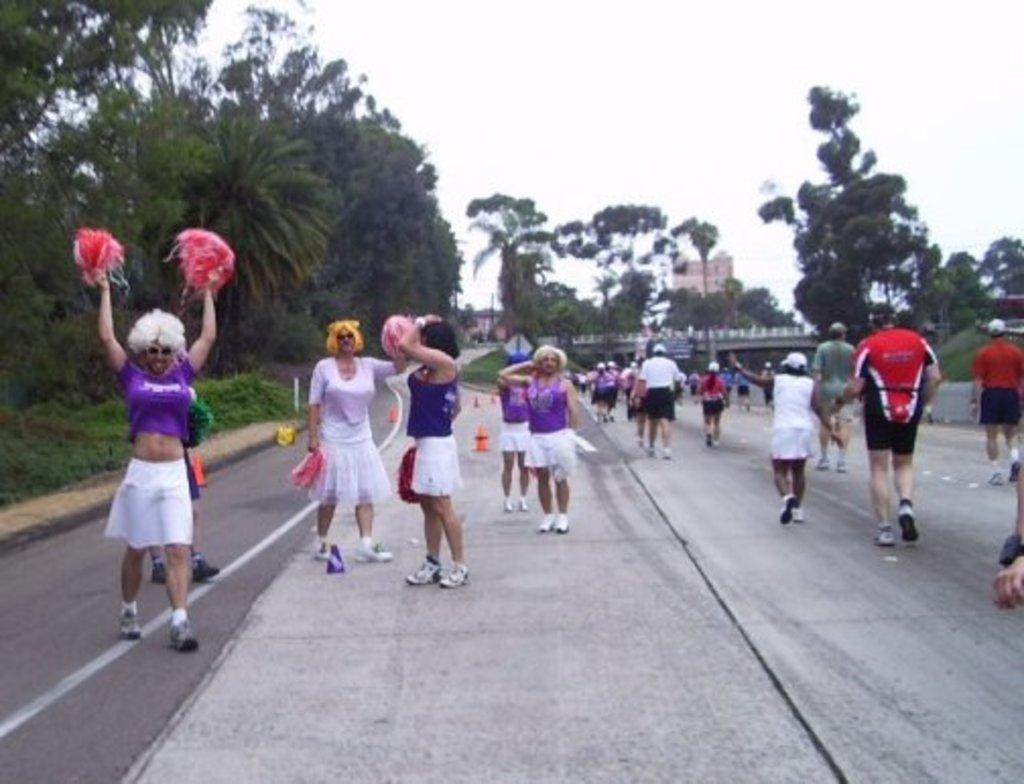What type of natural elements can be seen in the image? There are trees in the image. What type of man-made structures are present in the image? There are buildings in the image. Are there any living beings visible in the image? Yes, there are people in the image. What is visible at the top of the image? The sky is visible at the top of the image. What type of sign can be seen in the image? There is no sign present in the image. Is there a camp visible in the image? There is no camp present in the image. 